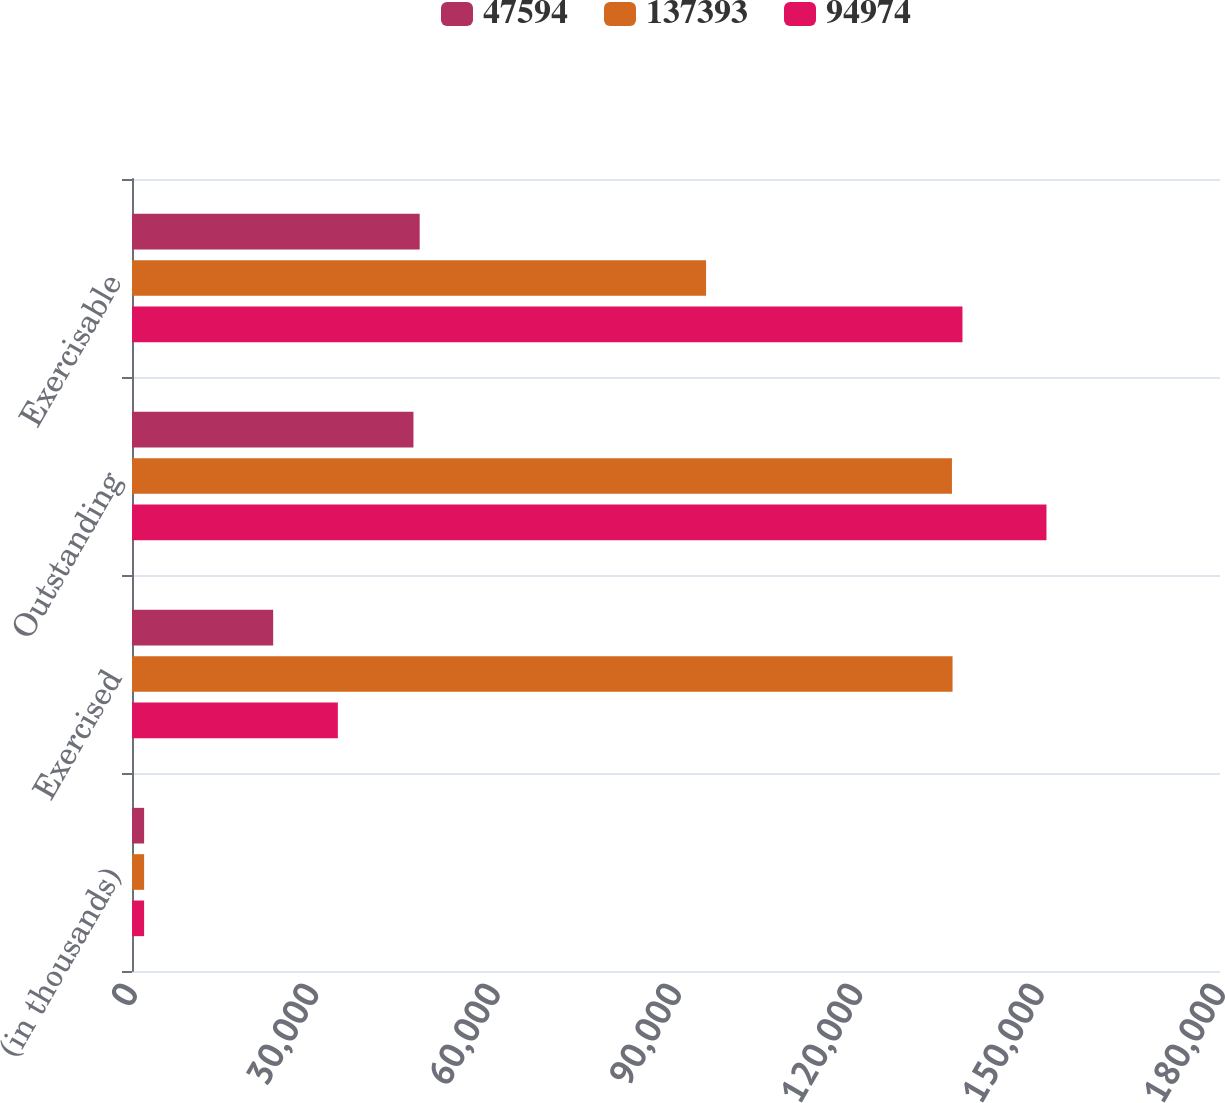Convert chart to OTSL. <chart><loc_0><loc_0><loc_500><loc_500><stacked_bar_chart><ecel><fcel>(in thousands)<fcel>Exercised<fcel>Outstanding<fcel>Exercisable<nl><fcel>47594<fcel>2005<fcel>23355<fcel>46564<fcel>47594<nl><fcel>137393<fcel>2004<fcel>135752<fcel>135652<fcel>94974<nl><fcel>94974<fcel>2003<fcel>34057<fcel>151290<fcel>137393<nl></chart> 